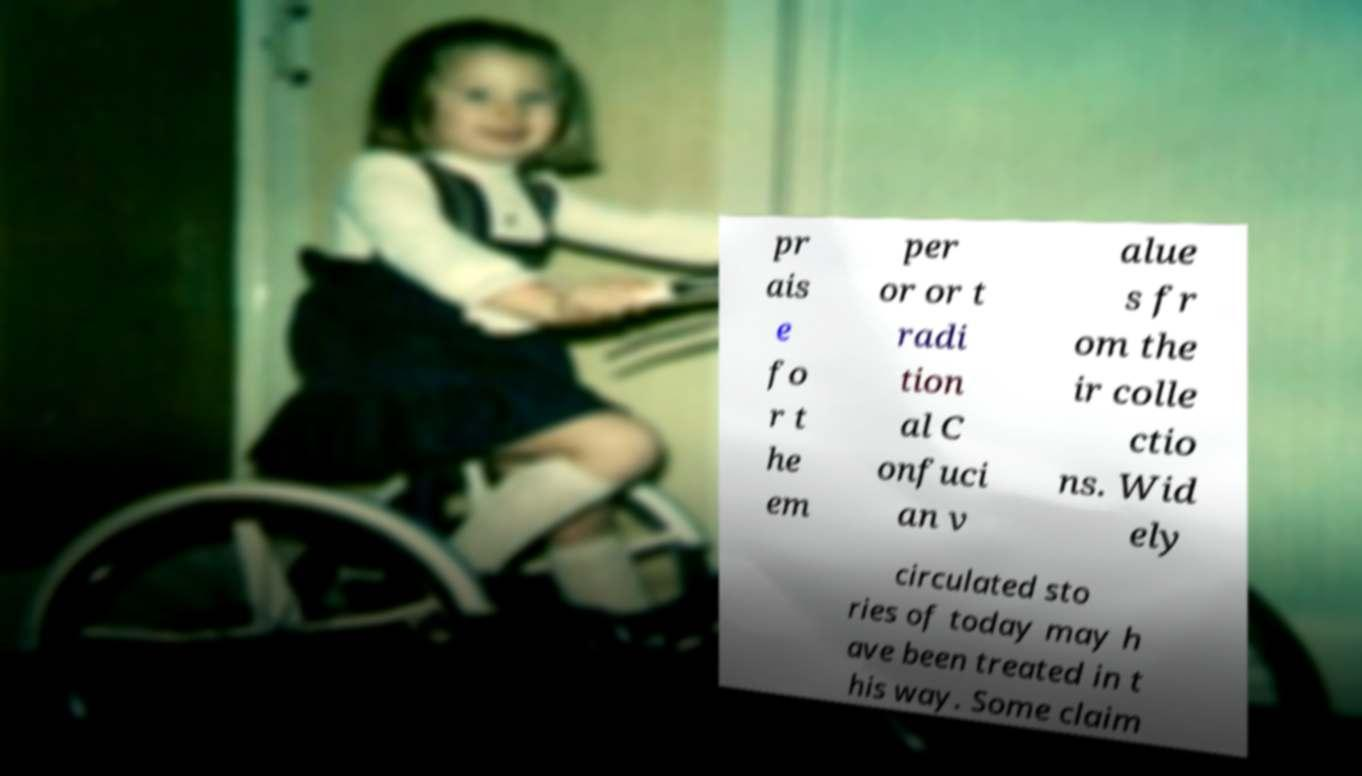For documentation purposes, I need the text within this image transcribed. Could you provide that? pr ais e fo r t he em per or or t radi tion al C onfuci an v alue s fr om the ir colle ctio ns. Wid ely circulated sto ries of today may h ave been treated in t his way. Some claim 